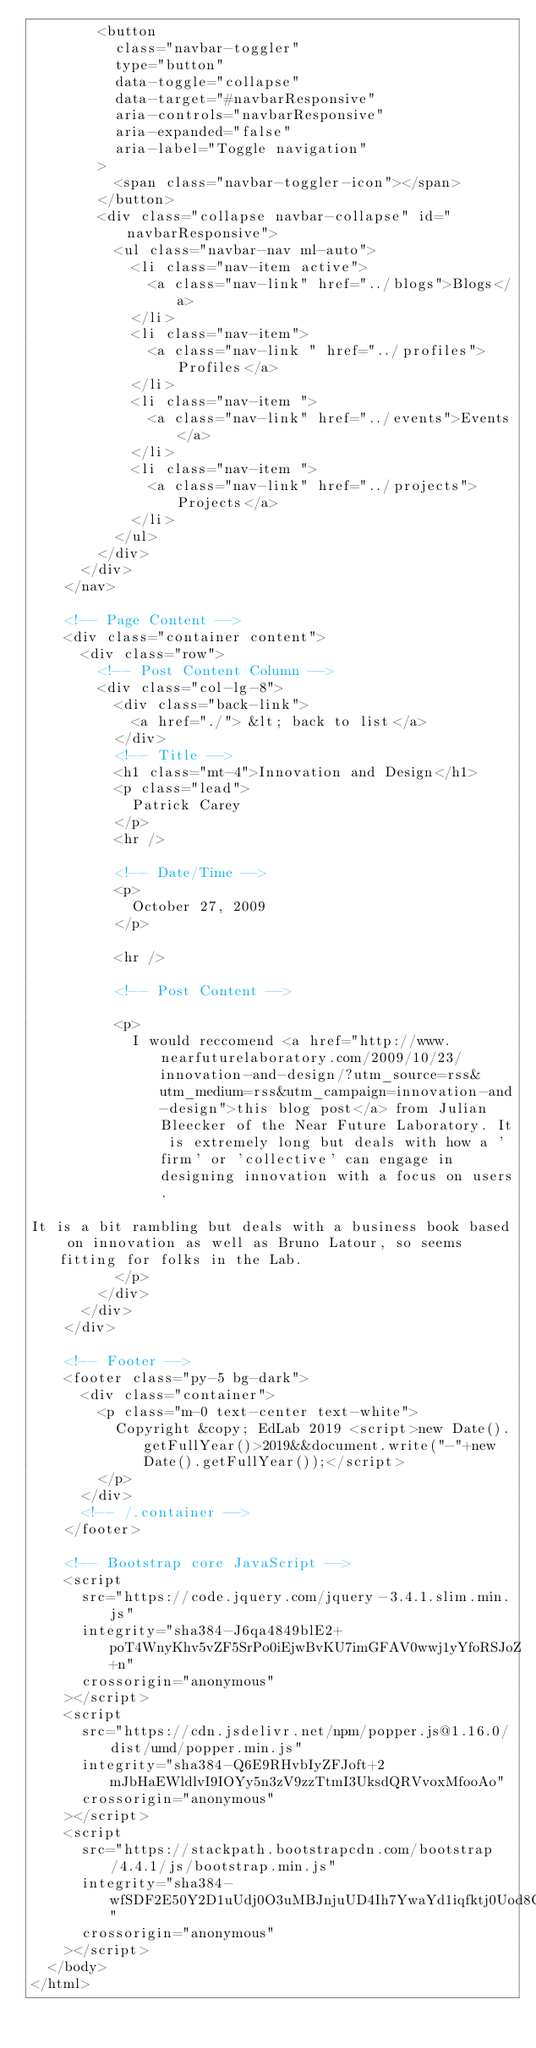<code> <loc_0><loc_0><loc_500><loc_500><_HTML_>        <button
          class="navbar-toggler"
          type="button"
          data-toggle="collapse"
          data-target="#navbarResponsive"
          aria-controls="navbarResponsive"
          aria-expanded="false"
          aria-label="Toggle navigation"
        >
          <span class="navbar-toggler-icon"></span>
        </button>
        <div class="collapse navbar-collapse" id="navbarResponsive">
          <ul class="navbar-nav ml-auto">
            <li class="nav-item active">
              <a class="nav-link" href="../blogs">Blogs</a>
            </li>
            <li class="nav-item">
              <a class="nav-link " href="../profiles">Profiles</a>
            </li>
            <li class="nav-item ">
              <a class="nav-link" href="../events">Events</a>
            </li>
            <li class="nav-item ">
              <a class="nav-link" href="../projects">Projects</a>
            </li>
          </ul>
        </div>
      </div>
    </nav>

    <!-- Page Content -->
    <div class="container content">
      <div class="row">
        <!-- Post Content Column -->
        <div class="col-lg-8">
          <div class="back-link">
            <a href="./"> &lt; back to list</a>
          </div>
          <!-- Title -->
          <h1 class="mt-4">Innovation and Design</h1>
          <p class="lead">
            Patrick Carey
          </p>
          <hr />

          <!-- Date/Time -->
          <p>
            October 27, 2009
          </p>

          <hr />

          <!-- Post Content -->

          <p>
            I would reccomend <a href="http://www.nearfuturelaboratory.com/2009/10/23/innovation-and-design/?utm_source=rss&utm_medium=rss&utm_campaign=innovation-and-design">this blog post</a> from Julian Bleecker of the Near Future Laboratory. It is extremely long but deals with how a 'firm' or 'collective' can engage in designing innovation with a focus on users.

It is a bit rambling but deals with a business book based on innovation as well as Bruno Latour, so seems fitting for folks in the Lab.
          </p>
        </div>
      </div>
    </div>

    <!-- Footer -->
    <footer class="py-5 bg-dark">
      <div class="container">
        <p class="m-0 text-center text-white">
          Copyright &copy; EdLab 2019 <script>new Date().getFullYear()>2019&&document.write("-"+new Date().getFullYear());</script>
        </p>
      </div>
      <!-- /.container -->
    </footer>

    <!-- Bootstrap core JavaScript -->
    <script
      src="https://code.jquery.com/jquery-3.4.1.slim.min.js"
      integrity="sha384-J6qa4849blE2+poT4WnyKhv5vZF5SrPo0iEjwBvKU7imGFAV0wwj1yYfoRSJoZ+n"
      crossorigin="anonymous"
    ></script>
    <script
      src="https://cdn.jsdelivr.net/npm/popper.js@1.16.0/dist/umd/popper.min.js"
      integrity="sha384-Q6E9RHvbIyZFJoft+2mJbHaEWldlvI9IOYy5n3zV9zzTtmI3UksdQRVvoxMfooAo"
      crossorigin="anonymous"
    ></script>
    <script
      src="https://stackpath.bootstrapcdn.com/bootstrap/4.4.1/js/bootstrap.min.js"
      integrity="sha384-wfSDF2E50Y2D1uUdj0O3uMBJnjuUD4Ih7YwaYd1iqfktj0Uod8GCExl3Og8ifwB6"
      crossorigin="anonymous"
    ></script>
  </body>
</html>
</code> 